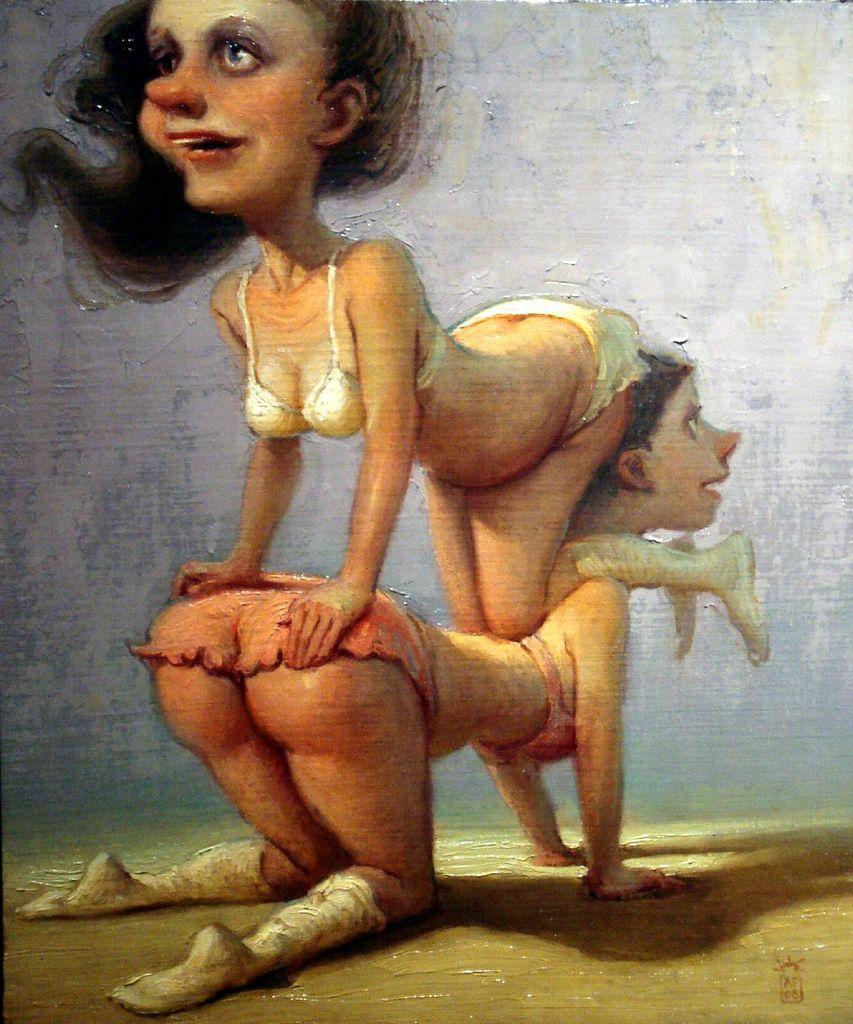What type of artwork is visible in the image? There are two women's paintings in the image. What is the background of the image? There is a wall in the image. What can be inferred about the nature of the image? The image appears to be a photo frame. What type of popcorn is being served in the image? There is no popcorn present in the image. How many holes can be seen in the wall in the image? The image does not provide enough detail to determine the number of holes in the wall. 